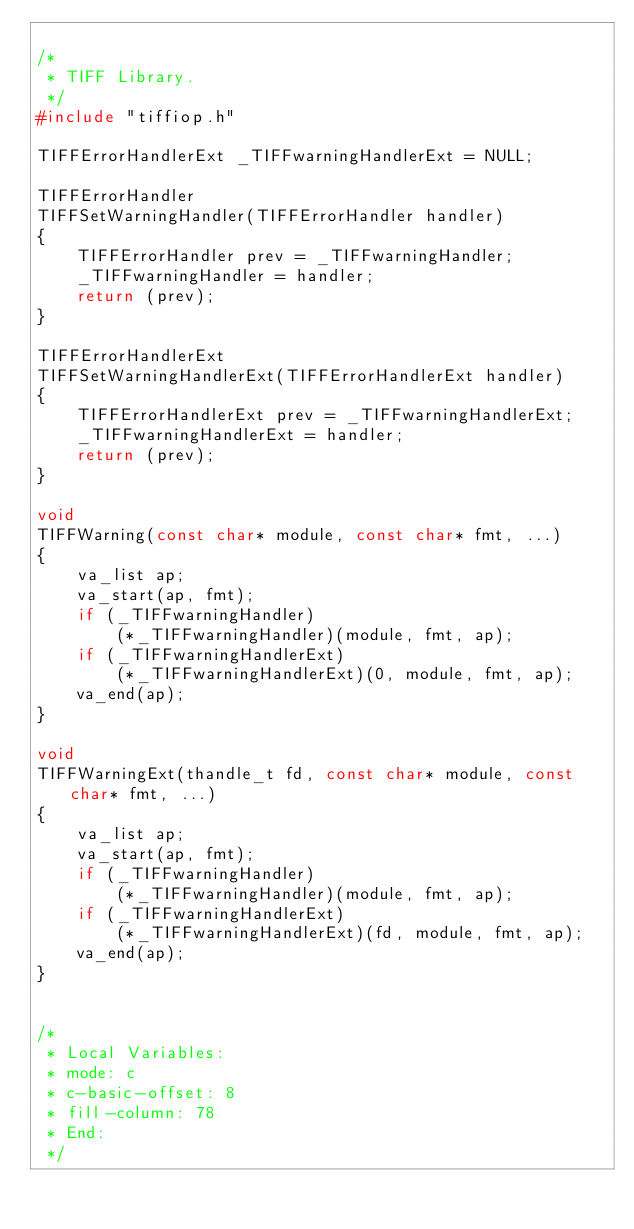Convert code to text. <code><loc_0><loc_0><loc_500><loc_500><_C_>
/*
 * TIFF Library.
 */
#include "tiffiop.h"

TIFFErrorHandlerExt _TIFFwarningHandlerExt = NULL;

TIFFErrorHandler
TIFFSetWarningHandler(TIFFErrorHandler handler)
{
	TIFFErrorHandler prev = _TIFFwarningHandler;
	_TIFFwarningHandler = handler;
	return (prev);
}

TIFFErrorHandlerExt
TIFFSetWarningHandlerExt(TIFFErrorHandlerExt handler)
{
	TIFFErrorHandlerExt prev = _TIFFwarningHandlerExt;
	_TIFFwarningHandlerExt = handler;
	return (prev);
}

void
TIFFWarning(const char* module, const char* fmt, ...)
{
	va_list ap;
	va_start(ap, fmt);
	if (_TIFFwarningHandler)
		(*_TIFFwarningHandler)(module, fmt, ap);
	if (_TIFFwarningHandlerExt)
		(*_TIFFwarningHandlerExt)(0, module, fmt, ap);
	va_end(ap);
}

void
TIFFWarningExt(thandle_t fd, const char* module, const char* fmt, ...)
{
	va_list ap;
	va_start(ap, fmt);
	if (_TIFFwarningHandler)
		(*_TIFFwarningHandler)(module, fmt, ap);
	if (_TIFFwarningHandlerExt)
		(*_TIFFwarningHandlerExt)(fd, module, fmt, ap);
	va_end(ap);
}


/*
 * Local Variables:
 * mode: c
 * c-basic-offset: 8
 * fill-column: 78
 * End:
 */
</code> 